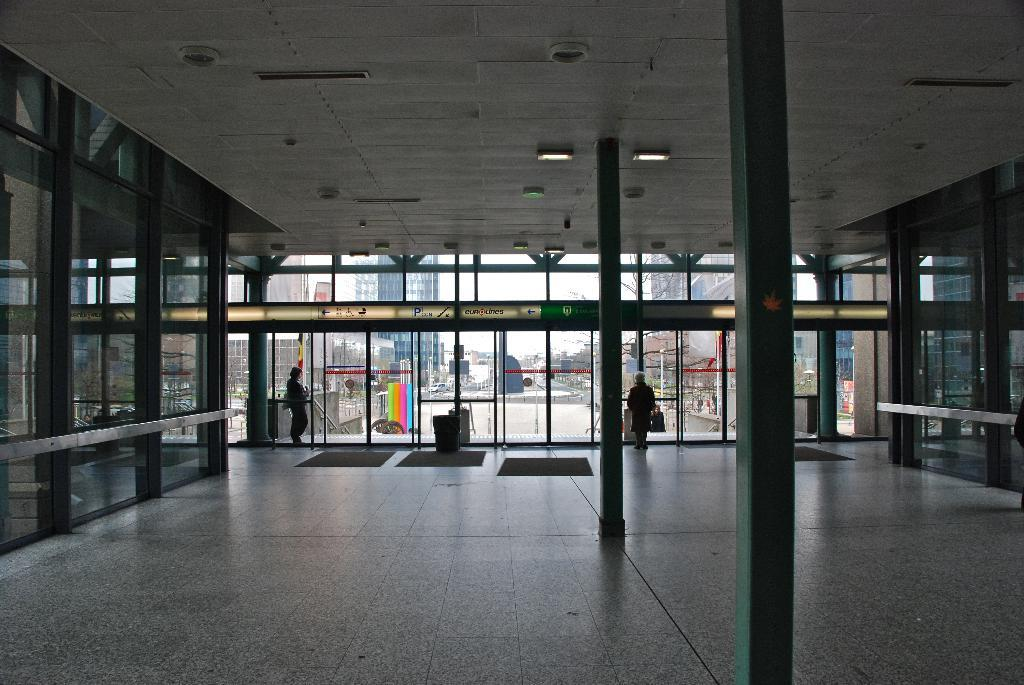What type of structures can be seen in the image? There are buildings in the image. What type of natural elements are present in the image? There are trees in the image. Can any human presence be observed in the image? Yes, there are people visible in the image. What type of floor covering is present in the image? There are floor mats in the image. What type of paint is being used by the lawyer on the coast in the image? There is no lawyer, paint, or coast present in the image. What type of legal advice is the lawyer providing to the people on the coast in the image? There is no lawyer or coast present in the image, so it is not possible to answer that question. 